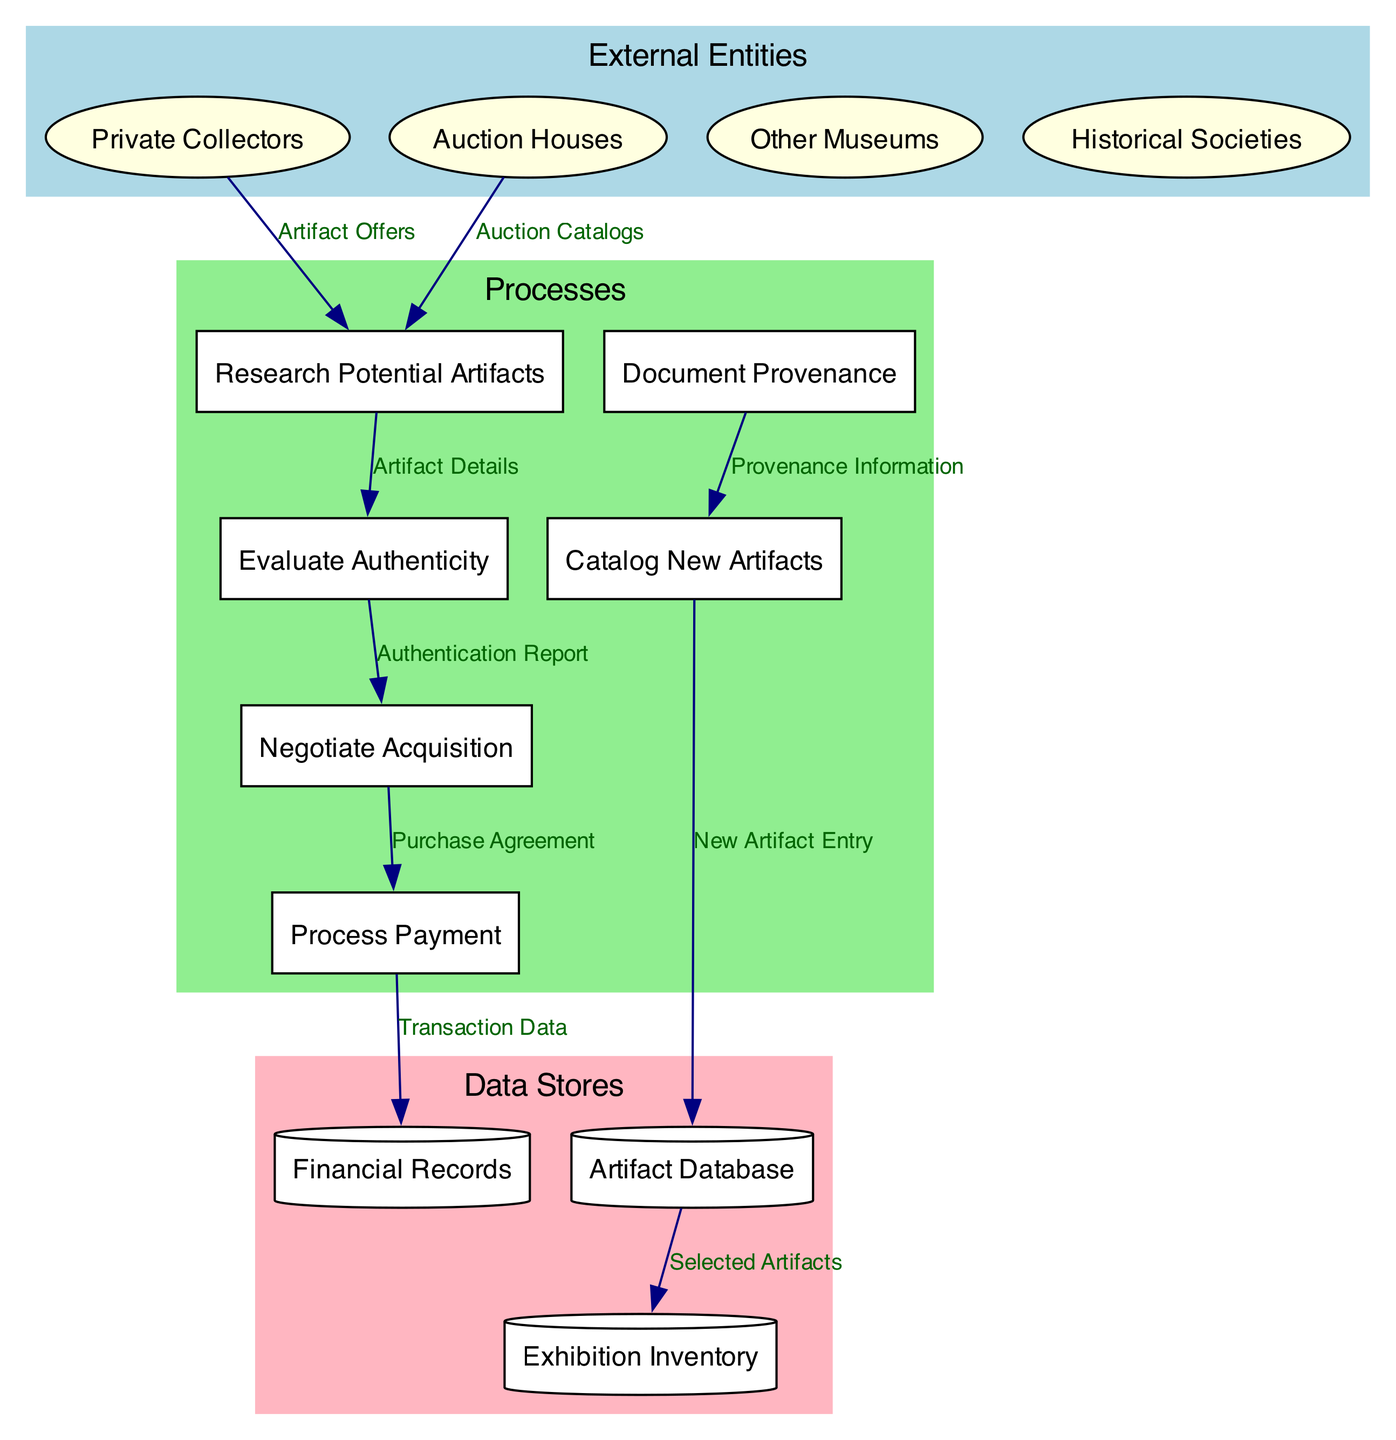What are the external entities involved in the artifact acquisition process? The diagram lists four external entities: Private Collectors, Auction Houses, Other Museums, and Historical Societies. These are the sources for potential artifacts.
Answer: Private Collectors, Auction Houses, Other Museums, Historical Societies How many processes are defined in the diagram? The diagram contains six distinct processes: Research Potential Artifacts, Evaluate Authenticity, Negotiate Acquisition, Process Payment, Document Provenance, and Catalog New Artifacts. Counting these processes gives us the total number.
Answer: 6 What data flows from "Research Potential Artifacts" to "Evaluate Authenticity"? The flow from "Research Potential Artifacts" to "Evaluate Authenticity" is labeled "Artifact Details", indicating the information that is transferred for evaluation.
Answer: Artifact Details Which entity provides "Auction Catalogs" to the process? The diagram shows that Auction Houses are the external entity providing "Auction Catalogs" to the process of Research Potential Artifacts. This identification comes from the flow direction and labeling.
Answer: Auction Houses Which process comes after "Evaluate Authenticity"? The sequence of processes in the diagram indicates that "Negotiate Acquisition" directly follows "Evaluate Authenticity" based on the connected data flows.
Answer: Negotiate Acquisition What is the final data store that receives new artifact entries? According to the diagram, the final data store receiving new artifact entries is the Artifact Database, where the selected artifacts are recorded after cataloging.
Answer: Artifact Database What type of information is documented in "Document Provenance"? The information labeled as "Provenance Information" is documented in the process "Document Provenance", which is crucial for tracking the artifacts' histories.
Answer: Provenance Information What is the purpose of "Process Payment"? The purpose of "Process Payment" is to handle financial transactions related to the acquisition of artifacts, as indicated by the data flows and related processes coming into it.
Answer: Handle financial transactions How many data stores are represented in the diagram? The diagram includes three data stores: Artifact Database, Exhibition Inventory, and Financial Records, which serve to store various types of information related to the acquisition process.
Answer: 3 